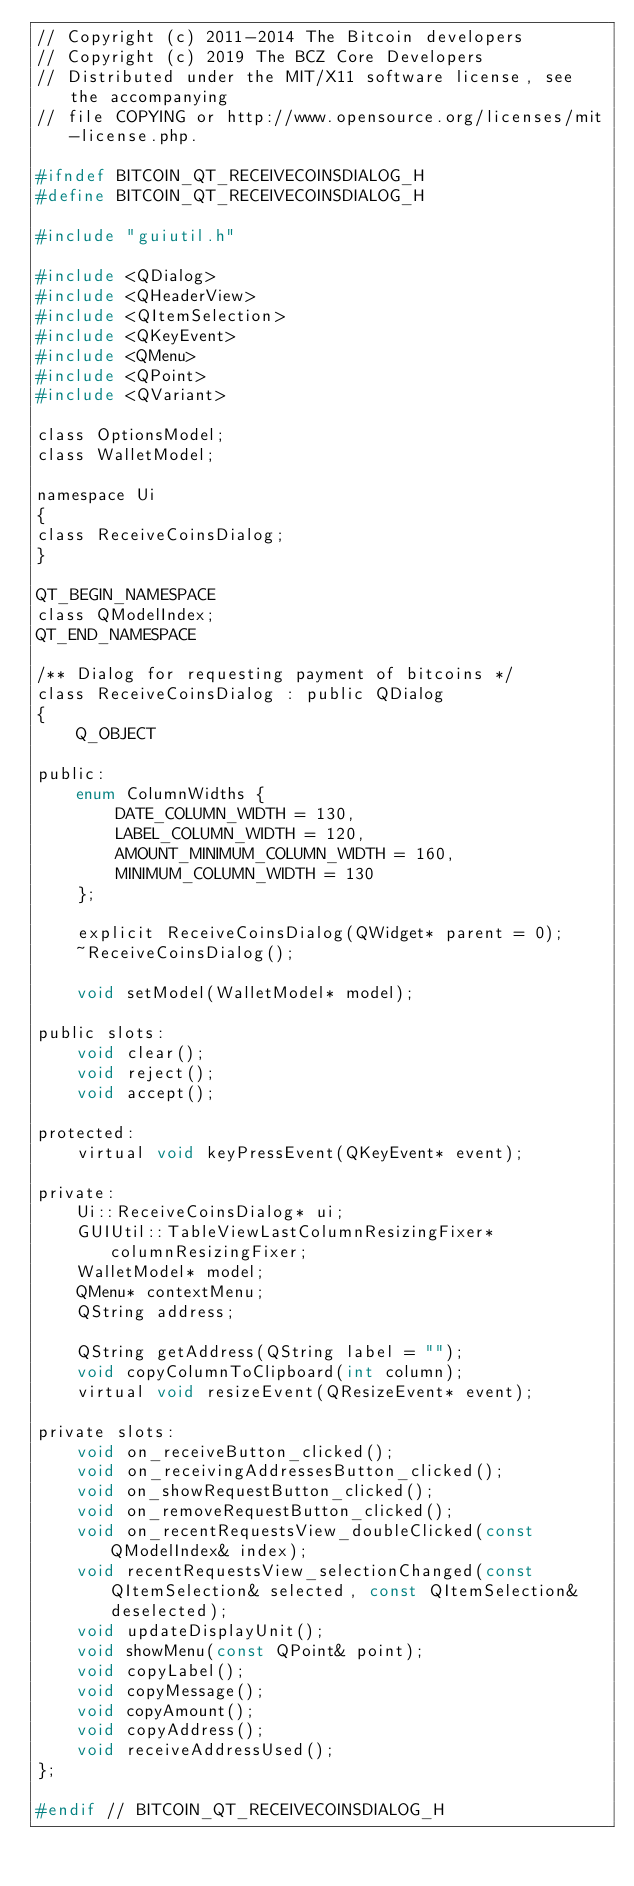<code> <loc_0><loc_0><loc_500><loc_500><_C_>// Copyright (c) 2011-2014 The Bitcoin developers
// Copyright (c) 2019 The BCZ Core Developers
// Distributed under the MIT/X11 software license, see the accompanying
// file COPYING or http://www.opensource.org/licenses/mit-license.php.

#ifndef BITCOIN_QT_RECEIVECOINSDIALOG_H
#define BITCOIN_QT_RECEIVECOINSDIALOG_H

#include "guiutil.h"

#include <QDialog>
#include <QHeaderView>
#include <QItemSelection>
#include <QKeyEvent>
#include <QMenu>
#include <QPoint>
#include <QVariant>

class OptionsModel;
class WalletModel;

namespace Ui
{
class ReceiveCoinsDialog;
}

QT_BEGIN_NAMESPACE
class QModelIndex;
QT_END_NAMESPACE

/** Dialog for requesting payment of bitcoins */
class ReceiveCoinsDialog : public QDialog
{
    Q_OBJECT

public:
    enum ColumnWidths {
        DATE_COLUMN_WIDTH = 130,
        LABEL_COLUMN_WIDTH = 120,
        AMOUNT_MINIMUM_COLUMN_WIDTH = 160,
        MINIMUM_COLUMN_WIDTH = 130
    };

    explicit ReceiveCoinsDialog(QWidget* parent = 0);
    ~ReceiveCoinsDialog();

    void setModel(WalletModel* model);

public slots:
    void clear();
    void reject();
    void accept();

protected:
    virtual void keyPressEvent(QKeyEvent* event);

private:
    Ui::ReceiveCoinsDialog* ui;
    GUIUtil::TableViewLastColumnResizingFixer* columnResizingFixer;
    WalletModel* model;
    QMenu* contextMenu;
    QString address;

    QString getAddress(QString label = "");
    void copyColumnToClipboard(int column);
    virtual void resizeEvent(QResizeEvent* event);

private slots:
    void on_receiveButton_clicked();
    void on_receivingAddressesButton_clicked();
    void on_showRequestButton_clicked();
    void on_removeRequestButton_clicked();
    void on_recentRequestsView_doubleClicked(const QModelIndex& index);
    void recentRequestsView_selectionChanged(const QItemSelection& selected, const QItemSelection& deselected);
    void updateDisplayUnit();
    void showMenu(const QPoint& point);
    void copyLabel();
    void copyMessage();
    void copyAmount();
    void copyAddress();
    void receiveAddressUsed();
};

#endif // BITCOIN_QT_RECEIVECOINSDIALOG_H
</code> 